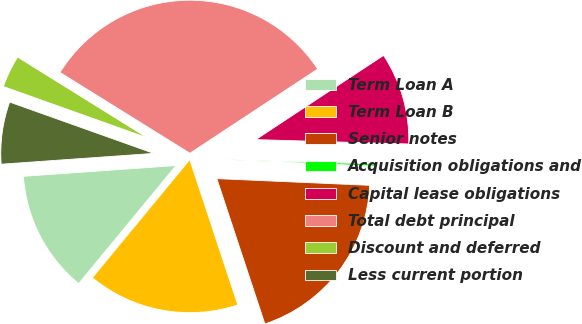<chart> <loc_0><loc_0><loc_500><loc_500><pie_chart><fcel>Term Loan A<fcel>Term Loan B<fcel>Senior notes<fcel>Acquisition obligations and<fcel>Capital lease obligations<fcel>Total debt principal<fcel>Discount and deferred<fcel>Less current portion<nl><fcel>12.9%<fcel>16.06%<fcel>19.22%<fcel>0.24%<fcel>9.73%<fcel>31.87%<fcel>3.41%<fcel>6.57%<nl></chart> 